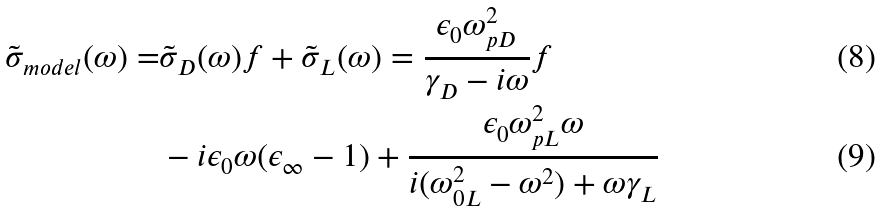<formula> <loc_0><loc_0><loc_500><loc_500>\tilde { \sigma } _ { m o d e l } ( \omega ) = & \tilde { \sigma } _ { D } ( \omega ) f + \tilde { \sigma } _ { L } ( \omega ) = \frac { \epsilon _ { 0 } \omega _ { p D } ^ { 2 } } { \gamma _ { D } - i \omega } f \\ & - i \epsilon _ { 0 } \omega ( \epsilon _ { \infty } - 1 ) + \frac { \epsilon _ { 0 } \omega _ { p L } ^ { 2 } \omega } { i ( \omega _ { 0 L } ^ { 2 } - \omega ^ { 2 } ) + \omega \gamma _ { L } }</formula> 